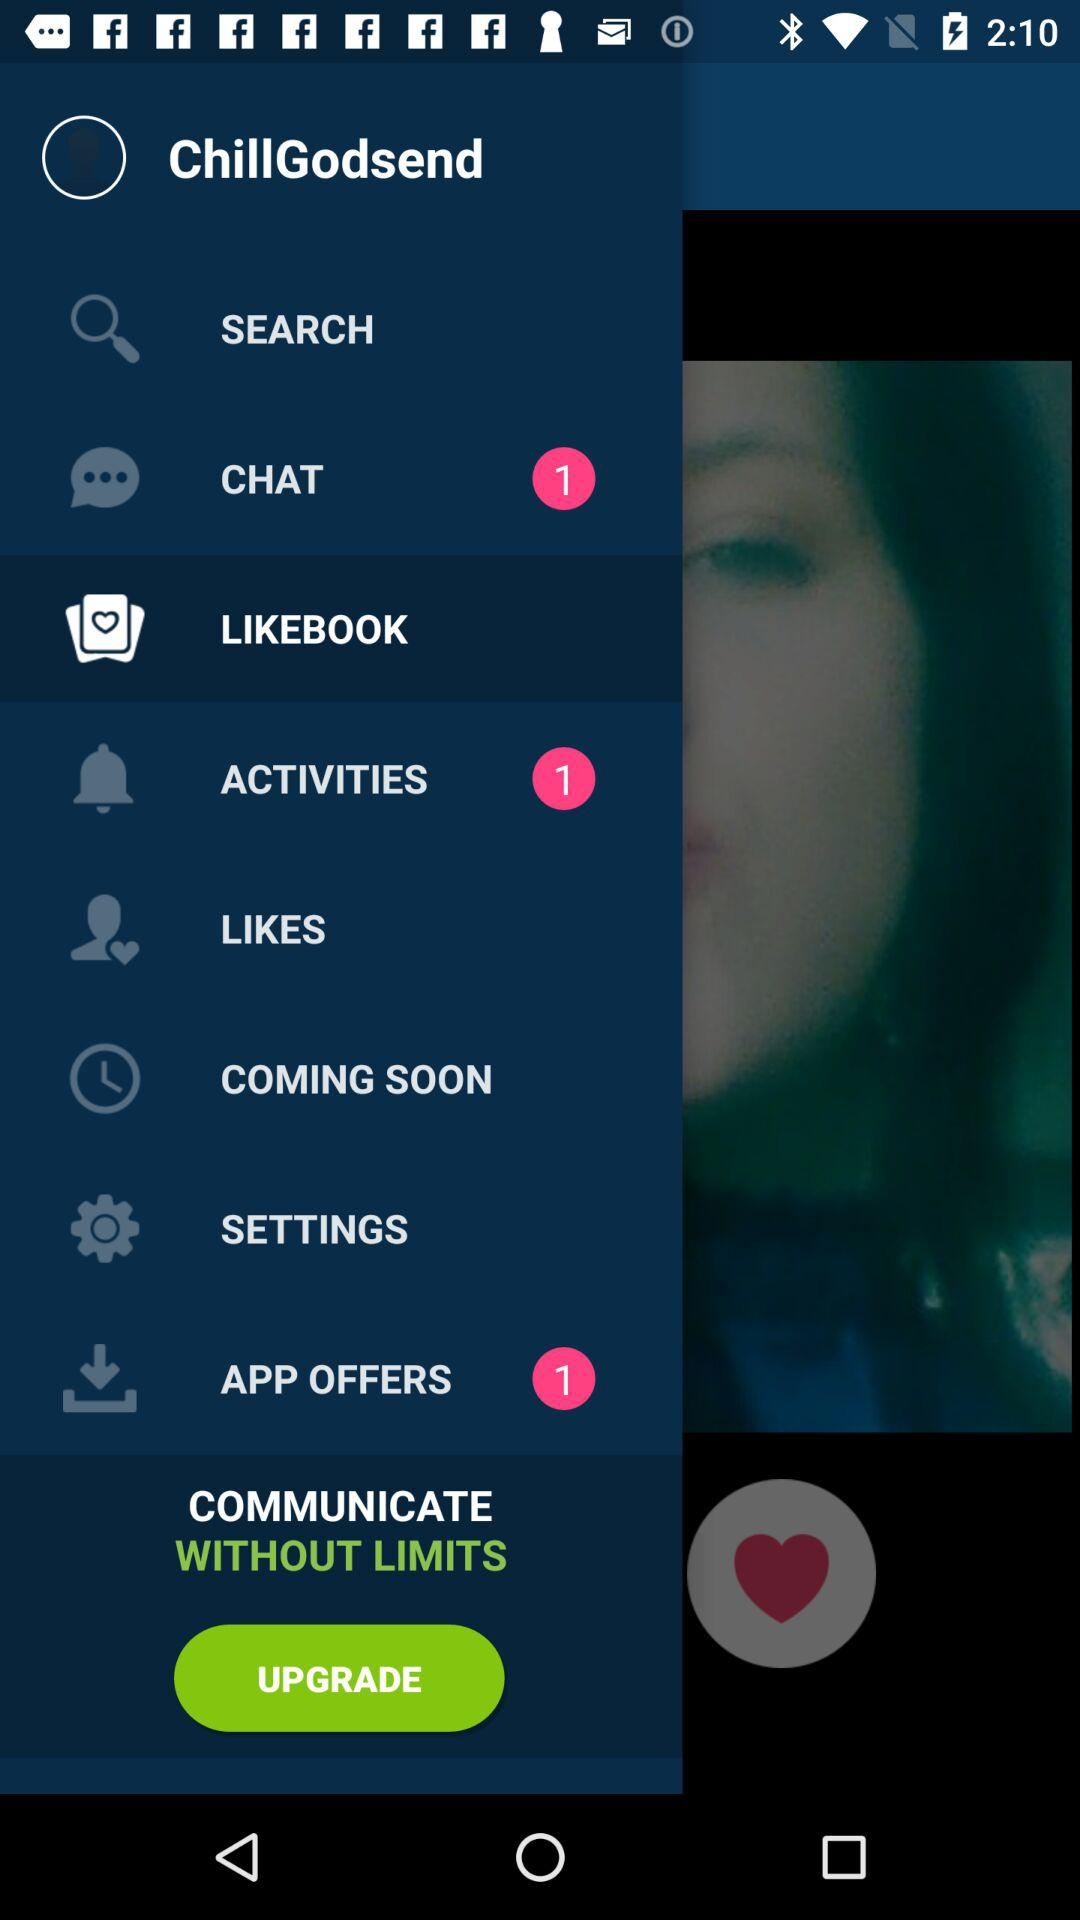How many activities are pending? There is 1 pending activity. 